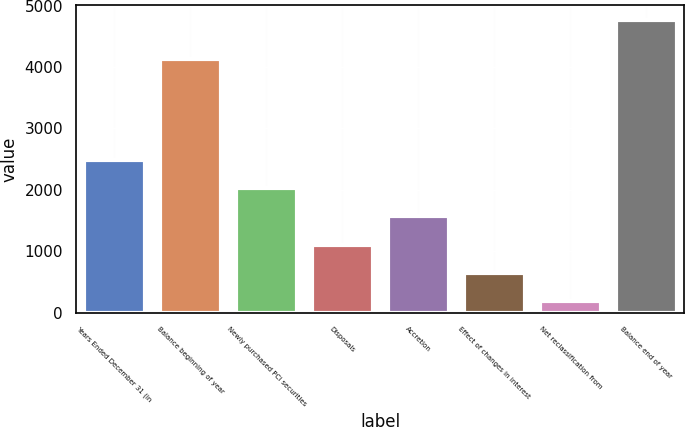Convert chart. <chart><loc_0><loc_0><loc_500><loc_500><bar_chart><fcel>Years Ended December 31 (in<fcel>Balance beginning of year<fcel>Newly purchased PCI securities<fcel>Disposals<fcel>Accretion<fcel>Effect of changes in interest<fcel>Net reclassification from<fcel>Balance end of year<nl><fcel>2480<fcel>4135<fcel>2022.8<fcel>1108.4<fcel>1565.6<fcel>651.2<fcel>194<fcel>4766<nl></chart> 